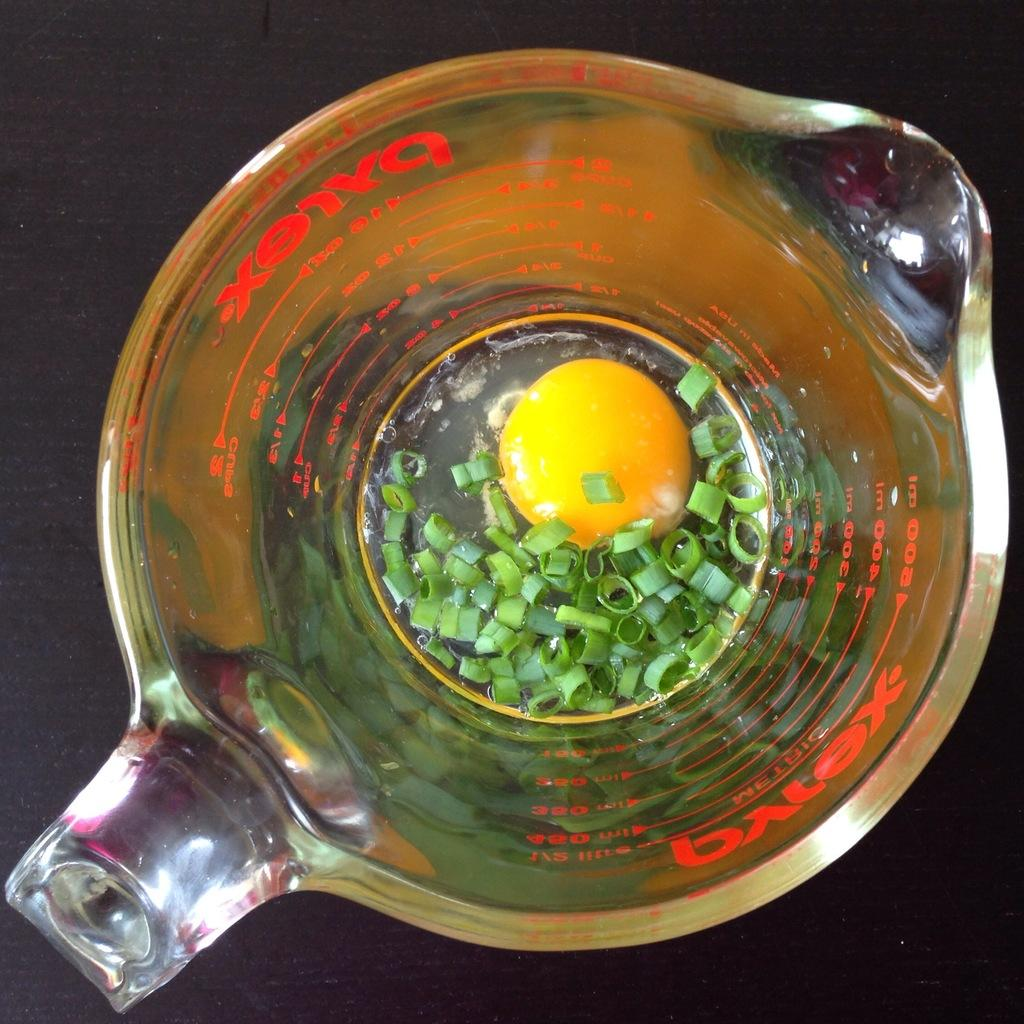<image>
Present a compact description of the photo's key features. A pyrex measuring up with an egg yolk insie. 